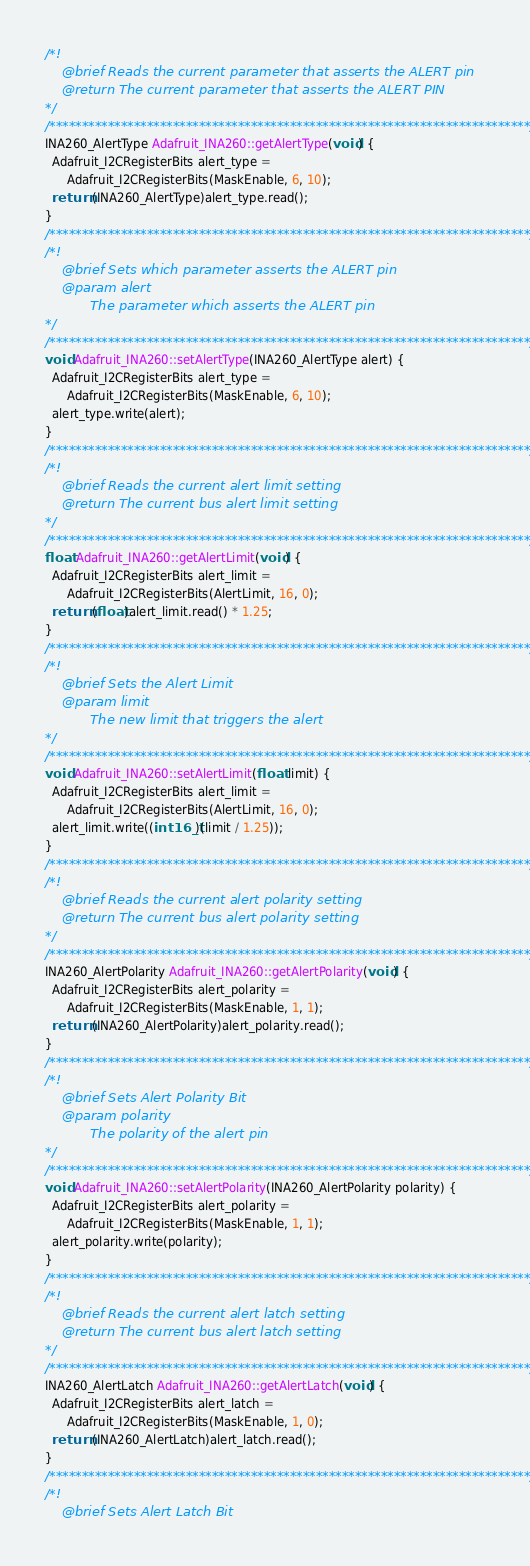<code> <loc_0><loc_0><loc_500><loc_500><_C++_>/*!
    @brief Reads the current parameter that asserts the ALERT pin
    @return The current parameter that asserts the ALERT PIN
*/
/**************************************************************************/
INA260_AlertType Adafruit_INA260::getAlertType(void) {
  Adafruit_I2CRegisterBits alert_type =
      Adafruit_I2CRegisterBits(MaskEnable, 6, 10);
  return (INA260_AlertType)alert_type.read();
}
/**************************************************************************/
/*!
    @brief Sets which parameter asserts the ALERT pin
    @param alert
           The parameter which asserts the ALERT pin
*/
/**************************************************************************/
void Adafruit_INA260::setAlertType(INA260_AlertType alert) {
  Adafruit_I2CRegisterBits alert_type =
      Adafruit_I2CRegisterBits(MaskEnable, 6, 10);
  alert_type.write(alert);
}
/**************************************************************************/
/*!
    @brief Reads the current alert limit setting
    @return The current bus alert limit setting
*/
/**************************************************************************/
float Adafruit_INA260::getAlertLimit(void) {
  Adafruit_I2CRegisterBits alert_limit =
      Adafruit_I2CRegisterBits(AlertLimit, 16, 0);
  return (float)alert_limit.read() * 1.25;
}
/**************************************************************************/
/*!
    @brief Sets the Alert Limit
    @param limit
           The new limit that triggers the alert
*/
/**************************************************************************/
void Adafruit_INA260::setAlertLimit(float limit) {
  Adafruit_I2CRegisterBits alert_limit =
      Adafruit_I2CRegisterBits(AlertLimit, 16, 0);
  alert_limit.write((int16_t)(limit / 1.25));
}
/**************************************************************************/
/*!
    @brief Reads the current alert polarity setting
    @return The current bus alert polarity setting
*/
/**************************************************************************/
INA260_AlertPolarity Adafruit_INA260::getAlertPolarity(void) {
  Adafruit_I2CRegisterBits alert_polarity =
      Adafruit_I2CRegisterBits(MaskEnable, 1, 1);
  return (INA260_AlertPolarity)alert_polarity.read();
}
/**************************************************************************/
/*!
    @brief Sets Alert Polarity Bit
    @param polarity
           The polarity of the alert pin
*/
/**************************************************************************/
void Adafruit_INA260::setAlertPolarity(INA260_AlertPolarity polarity) {
  Adafruit_I2CRegisterBits alert_polarity =
      Adafruit_I2CRegisterBits(MaskEnable, 1, 1);
  alert_polarity.write(polarity);
}
/**************************************************************************/
/*!
    @brief Reads the current alert latch setting
    @return The current bus alert latch setting
*/
/**************************************************************************/
INA260_AlertLatch Adafruit_INA260::getAlertLatch(void) {
  Adafruit_I2CRegisterBits alert_latch =
      Adafruit_I2CRegisterBits(MaskEnable, 1, 0);
  return (INA260_AlertLatch)alert_latch.read();
}
/**************************************************************************/
/*!
    @brief Sets Alert Latch Bit</code> 